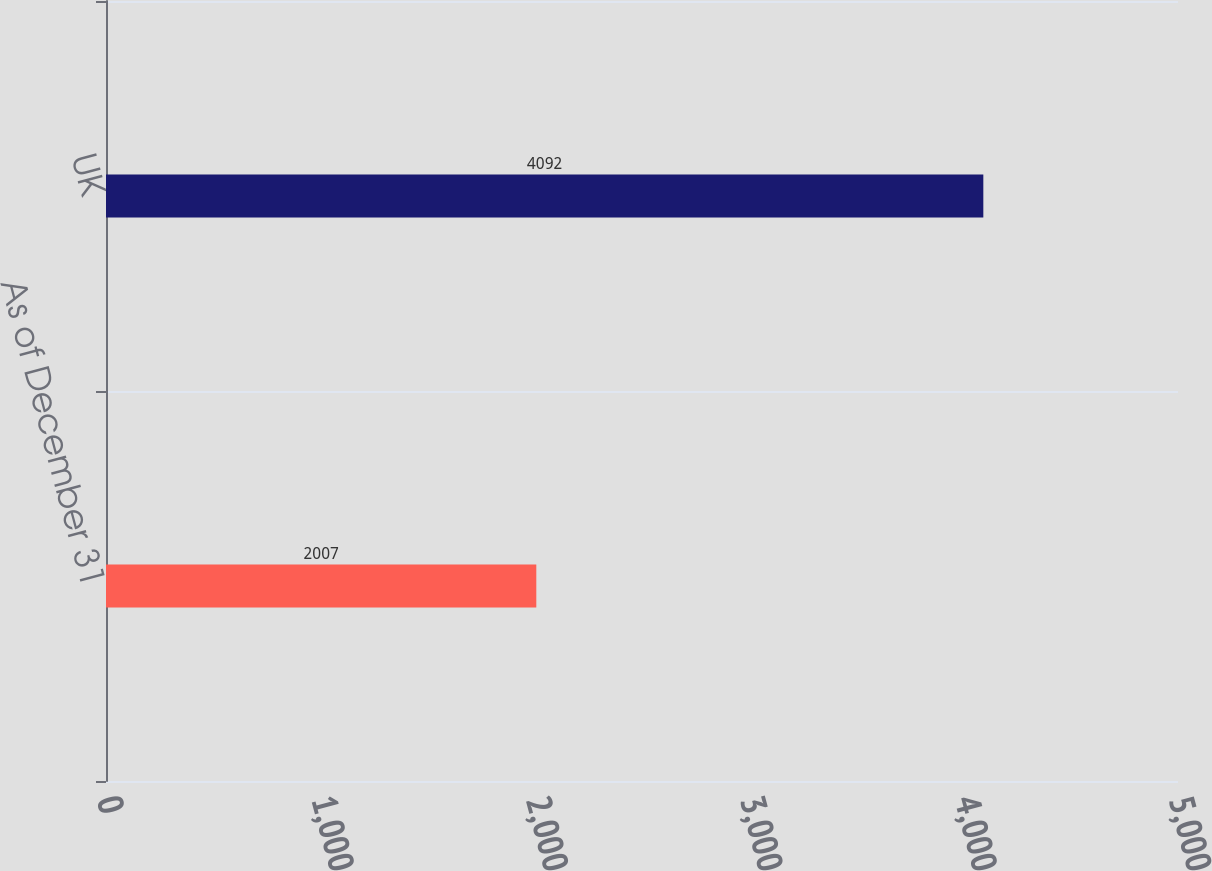<chart> <loc_0><loc_0><loc_500><loc_500><bar_chart><fcel>As of December 31<fcel>UK<nl><fcel>2007<fcel>4092<nl></chart> 